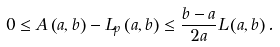Convert formula to latex. <formula><loc_0><loc_0><loc_500><loc_500>0 \leq A \left ( a , b \right ) - L _ { p } \left ( a , b \right ) \leq \frac { b - a } { 2 a } L \left ( a , b \right ) .</formula> 